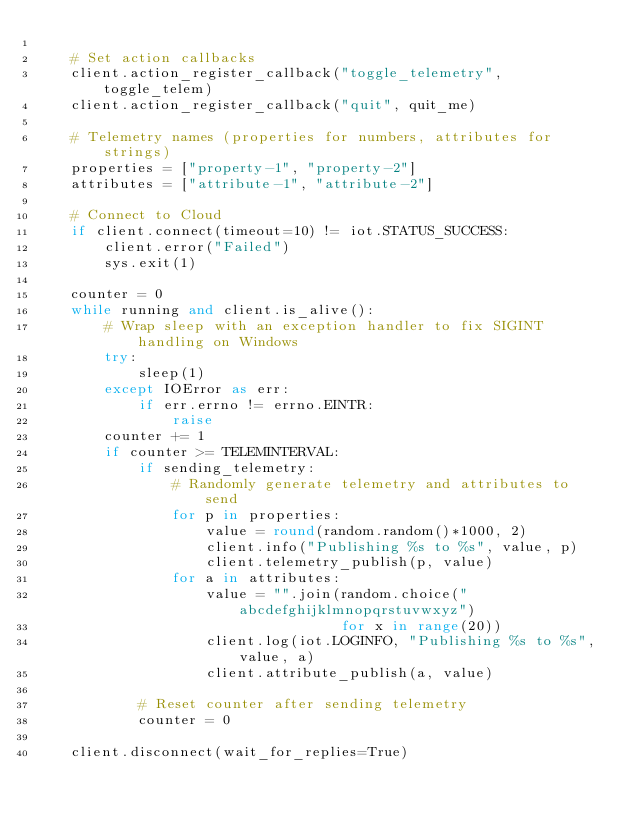Convert code to text. <code><loc_0><loc_0><loc_500><loc_500><_Python_>
    # Set action callbacks
    client.action_register_callback("toggle_telemetry", toggle_telem)
    client.action_register_callback("quit", quit_me)

    # Telemetry names (properties for numbers, attributes for strings)
    properties = ["property-1", "property-2"]
    attributes = ["attribute-1", "attribute-2"]

    # Connect to Cloud
    if client.connect(timeout=10) != iot.STATUS_SUCCESS:
        client.error("Failed")
        sys.exit(1)

    counter = 0
    while running and client.is_alive():
        # Wrap sleep with an exception handler to fix SIGINT handling on Windows
        try:
            sleep(1)
        except IOError as err:
            if err.errno != errno.EINTR:
                raise
        counter += 1
        if counter >= TELEMINTERVAL:
            if sending_telemetry:
                # Randomly generate telemetry and attributes to send
                for p in properties:
                    value = round(random.random()*1000, 2)
                    client.info("Publishing %s to %s", value, p)
                    client.telemetry_publish(p, value)
                for a in attributes:
                    value = "".join(random.choice("abcdefghijklmnopqrstuvwxyz")
                                    for x in range(20))
                    client.log(iot.LOGINFO, "Publishing %s to %s", value, a)
                    client.attribute_publish(a, value)

            # Reset counter after sending telemetry
            counter = 0

    client.disconnect(wait_for_replies=True)

</code> 